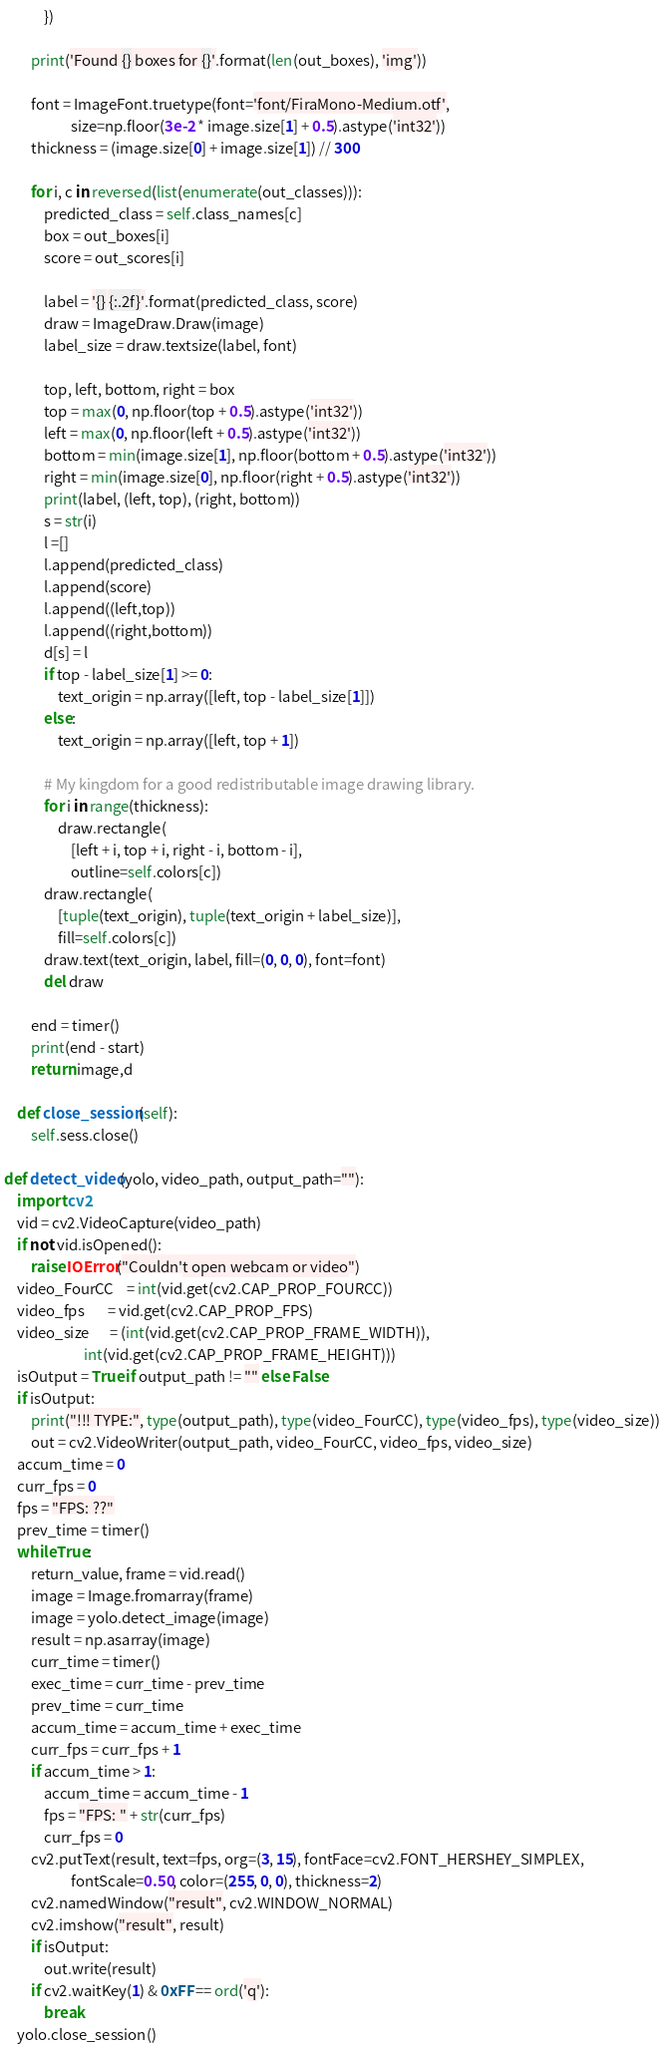Convert code to text. <code><loc_0><loc_0><loc_500><loc_500><_Python_>            })

        print('Found {} boxes for {}'.format(len(out_boxes), 'img'))

        font = ImageFont.truetype(font='font/FiraMono-Medium.otf',
                    size=np.floor(3e-2 * image.size[1] + 0.5).astype('int32'))
        thickness = (image.size[0] + image.size[1]) // 300

        for i, c in reversed(list(enumerate(out_classes))):
            predicted_class = self.class_names[c]
            box = out_boxes[i]
            score = out_scores[i]

            label = '{} {:.2f}'.format(predicted_class, score)
            draw = ImageDraw.Draw(image)
            label_size = draw.textsize(label, font)

            top, left, bottom, right = box
            top = max(0, np.floor(top + 0.5).astype('int32'))
            left = max(0, np.floor(left + 0.5).astype('int32'))
            bottom = min(image.size[1], np.floor(bottom + 0.5).astype('int32'))
            right = min(image.size[0], np.floor(right + 0.5).astype('int32'))
            print(label, (left, top), (right, bottom))
            s = str(i)
            l =[]
            l.append(predicted_class)
            l.append(score)
            l.append((left,top))
            l.append((right,bottom))
            d[s] = l
            if top - label_size[1] >= 0:
                text_origin = np.array([left, top - label_size[1]])
            else:
                text_origin = np.array([left, top + 1])

            # My kingdom for a good redistributable image drawing library.
            for i in range(thickness):
                draw.rectangle(
                    [left + i, top + i, right - i, bottom - i],
                    outline=self.colors[c])
            draw.rectangle(
                [tuple(text_origin), tuple(text_origin + label_size)],
                fill=self.colors[c])
            draw.text(text_origin, label, fill=(0, 0, 0), font=font)
            del draw

        end = timer()
        print(end - start)
        return image,d

    def close_session(self):
        self.sess.close()

def detect_video(yolo, video_path, output_path=""):
    import cv2
    vid = cv2.VideoCapture(video_path)
    if not vid.isOpened():
        raise IOError("Couldn't open webcam or video")
    video_FourCC    = int(vid.get(cv2.CAP_PROP_FOURCC))
    video_fps       = vid.get(cv2.CAP_PROP_FPS)
    video_size      = (int(vid.get(cv2.CAP_PROP_FRAME_WIDTH)),
                        int(vid.get(cv2.CAP_PROP_FRAME_HEIGHT)))
    isOutput = True if output_path != "" else False
    if isOutput:
        print("!!! TYPE:", type(output_path), type(video_FourCC), type(video_fps), type(video_size))
        out = cv2.VideoWriter(output_path, video_FourCC, video_fps, video_size)
    accum_time = 0
    curr_fps = 0
    fps = "FPS: ??"
    prev_time = timer()
    while True:
        return_value, frame = vid.read()
        image = Image.fromarray(frame)
        image = yolo.detect_image(image)
        result = np.asarray(image)
        curr_time = timer()
        exec_time = curr_time - prev_time
        prev_time = curr_time
        accum_time = accum_time + exec_time
        curr_fps = curr_fps + 1
        if accum_time > 1:
            accum_time = accum_time - 1
            fps = "FPS: " + str(curr_fps)
            curr_fps = 0
        cv2.putText(result, text=fps, org=(3, 15), fontFace=cv2.FONT_HERSHEY_SIMPLEX,
                    fontScale=0.50, color=(255, 0, 0), thickness=2)
        cv2.namedWindow("result", cv2.WINDOW_NORMAL)
        cv2.imshow("result", result)
        if isOutput:
            out.write(result)
        if cv2.waitKey(1) & 0xFF == ord('q'):
            break
    yolo.close_session()

</code> 